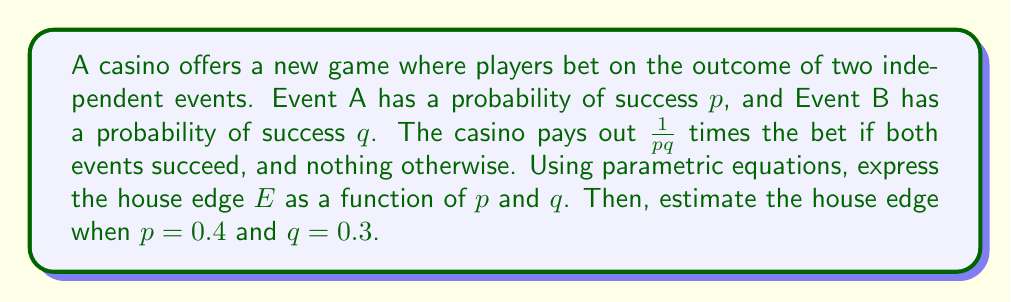Give your solution to this math problem. Let's approach this step-by-step:

1) First, we need to define the expected value of the player's winnings. The player wins only if both events succeed, which has a probability of $pq$. The payout is $\frac{1}{pq}$ times the bet.

2) Let's assume a bet of 1 unit. The expected value (EV) of the player's winnings is:

   $$EV = pq \cdot \frac{1}{pq} = 1$$

3) The house edge is defined as the expected loss for the player as a percentage of the initial bet. It can be calculated as:

   $$E = 1 - EV$$

4) Substituting our EV:

   $$E = 1 - 1 = 0$$

5) This means that, theoretically, this game has no house edge. However, casinos rarely offer games without an edge. Let's introduce a parameter $k$ where the casino pays out $\frac{k}{pq}$ instead of $\frac{1}{pq}$. Now our equations become:

   $$EV = pq \cdot \frac{k}{pq} = k$$
   $$E = 1 - k$$

6) This parametric equation represents the house edge as a function of $k$, $p$, and $q$.

7) To estimate the house edge when $p = 0.4$ and $q = 0.3$, we need to know $k$. Since we don't have this information, we can't provide an exact estimate. However, if the casino wants a 5% edge, they would set $k = 0.95$, resulting in:

   $$E = 1 - 0.95 = 0.05 = 5\%$$

This 5% edge would be consistent regardless of the values of $p$ and $q$.
Answer: The house edge can be expressed as $E = 1 - k$, where $k$ is the fraction of the theoretical fair payout that the casino actually pays. Without knowing $k$, we cannot estimate the exact house edge for $p = 0.4$ and $q = 0.3$. However, if the casino aims for a typical 5% edge, they would set $k = 0.95$, resulting in a 5% house edge regardless of $p$ and $q$ values. 